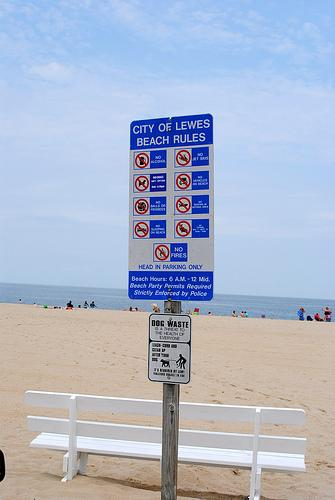Identify any wildlife depicted in the image and their attributes. There is the figure of a dog, shown in a simplistic form with a height of 11 units and a width of 11 units (160, 357). What kind of bench is present in the image and where is it located? A white wooden bench is present in the image, located on the sand at the beach near a wooden post where the signs are posted. Can you count how many signs are present in the image and provide a brief description of each? There are two signs present - a blue and white sign with white writing, red circles with cross, and a wooden pole attached, and a black and white sign with a dog and human icon, providing information on walking dogs on the beach. What is the condition of the sand at the beach and are there any distinctive marks on it? The sand on the beach is clean, but there are tracks in the sand from people walking and a shadow from the white bench. Discuss the image's sentiment using elements like the sky, ocean, and beach. The image has a calm and positive sentiment, as it features clear blue sky with white clouds, beautiful blue ocean water, clean sand, and people enjoying the beach. How would you describe the appearance and location of the trashcan? The trashcan is black and small with a height of 19 units and width of 19 units, located at the image's bottom-left corner with coordinates (0, 466). Provide a general overview of the image, focusing on major subjects and their relations. The image features a calm beach with clean sand and people enjoying the shore. A white wooden bench overlooks the ocean, sitting on the sand near a wooden post with two signs about beach rules and dog walking. In the context of the image, what is placed on the wooden pole? There are two signs: one blue and white sign with white writing and red circles with cross, another black and white sign with a dog and human icon and information about walking your dog. Describe the scene of people present on the beach. There are multiple people on the beach, some sitting and some standing, enjoying the calm atmosphere, beautiful blue ocean water, and clear blue sky in the distance. Which colors dominate the beach sign and what does it convey? The beach sign is dominated by blue and white colors with white writing on the blue part and red circles with cross. It conveys a very long list of rules for the beach and information about walking dogs. 